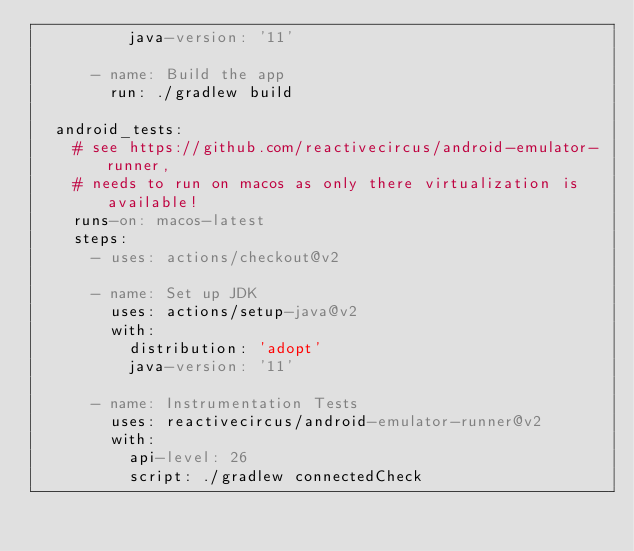Convert code to text. <code><loc_0><loc_0><loc_500><loc_500><_YAML_>          java-version: '11'

      - name: Build the app
        run: ./gradlew build

  android_tests:
    # see https://github.com/reactivecircus/android-emulator-runner,
    # needs to run on macos as only there virtualization is available!
    runs-on: macos-latest
    steps:
      - uses: actions/checkout@v2

      - name: Set up JDK
        uses: actions/setup-java@v2
        with:
          distribution: 'adopt'
          java-version: '11'

      - name: Instrumentation Tests
        uses: reactivecircus/android-emulator-runner@v2
        with:
          api-level: 26
          script: ./gradlew connectedCheck
</code> 